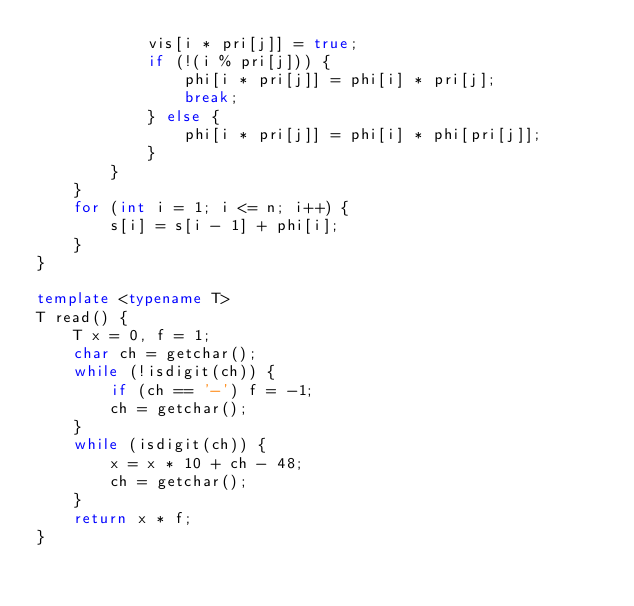<code> <loc_0><loc_0><loc_500><loc_500><_C++_>            vis[i * pri[j]] = true;
            if (!(i % pri[j])) {
                phi[i * pri[j]] = phi[i] * pri[j];
                break;
            } else {
                phi[i * pri[j]] = phi[i] * phi[pri[j]];
            }
        }
    }
    for (int i = 1; i <= n; i++) {
        s[i] = s[i - 1] + phi[i];
    }
}

template <typename T>
T read() {
    T x = 0, f = 1;
    char ch = getchar();
    while (!isdigit(ch)) {
        if (ch == '-') f = -1;
        ch = getchar();
    }
    while (isdigit(ch)) {
        x = x * 10 + ch - 48;
        ch = getchar();
    }
    return x * f;
}</code> 